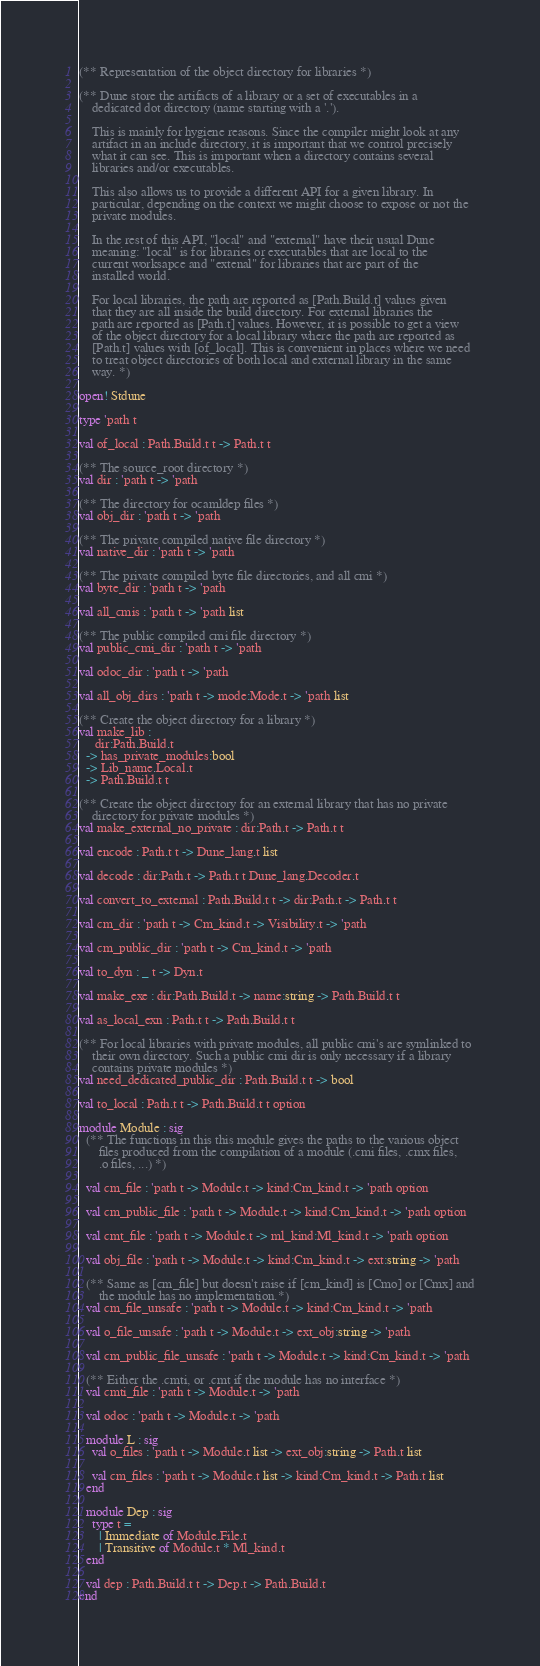<code> <loc_0><loc_0><loc_500><loc_500><_OCaml_>(** Representation of the object directory for libraries *)

(** Dune store the artifacts of a library or a set of executables in a
    dedicated dot directory (name starting with a '.').

    This is mainly for hygiene reasons. Since the compiler might look at any
    artifact in an include directory, it is important that we control precisely
    what it can see. This is important when a directory contains several
    libraries and/or executables.

    This also allows us to provide a different API for a given library. In
    particular, depending on the context we might choose to expose or not the
    private modules.

    In the rest of this API, "local" and "external" have their usual Dune
    meaning: "local" is for libraries or executables that are local to the
    current worksapce and "extenal" for libraries that are part of the
    installed world.

    For local libraries, the path are reported as [Path.Build.t] values given
    that they are all inside the build directory. For external libraries the
    path are reported as [Path.t] values. However, it is possible to get a view
    of the object directory for a local library where the path are reported as
    [Path.t] values with [of_local]. This is convenient in places where we need
    to treat object directories of both local and external library in the same
    way. *)

open! Stdune

type 'path t

val of_local : Path.Build.t t -> Path.t t

(** The source_root directory *)
val dir : 'path t -> 'path

(** The directory for ocamldep files *)
val obj_dir : 'path t -> 'path

(** The private compiled native file directory *)
val native_dir : 'path t -> 'path

(** The private compiled byte file directories, and all cmi *)
val byte_dir : 'path t -> 'path

val all_cmis : 'path t -> 'path list

(** The public compiled cmi file directory *)
val public_cmi_dir : 'path t -> 'path

val odoc_dir : 'path t -> 'path

val all_obj_dirs : 'path t -> mode:Mode.t -> 'path list

(** Create the object directory for a library *)
val make_lib :
     dir:Path.Build.t
  -> has_private_modules:bool
  -> Lib_name.Local.t
  -> Path.Build.t t

(** Create the object directory for an external library that has no private
    directory for private modules *)
val make_external_no_private : dir:Path.t -> Path.t t

val encode : Path.t t -> Dune_lang.t list

val decode : dir:Path.t -> Path.t t Dune_lang.Decoder.t

val convert_to_external : Path.Build.t t -> dir:Path.t -> Path.t t

val cm_dir : 'path t -> Cm_kind.t -> Visibility.t -> 'path

val cm_public_dir : 'path t -> Cm_kind.t -> 'path

val to_dyn : _ t -> Dyn.t

val make_exe : dir:Path.Build.t -> name:string -> Path.Build.t t

val as_local_exn : Path.t t -> Path.Build.t t

(** For local libraries with private modules, all public cmi's are symlinked to
    their own directory. Such a public cmi dir is only necessary if a library
    contains private modules *)
val need_dedicated_public_dir : Path.Build.t t -> bool

val to_local : Path.t t -> Path.Build.t t option

module Module : sig
  (** The functions in this this module gives the paths to the various object
      files produced from the compilation of a module (.cmi files, .cmx files,
      .o files, ...) *)

  val cm_file : 'path t -> Module.t -> kind:Cm_kind.t -> 'path option

  val cm_public_file : 'path t -> Module.t -> kind:Cm_kind.t -> 'path option

  val cmt_file : 'path t -> Module.t -> ml_kind:Ml_kind.t -> 'path option

  val obj_file : 'path t -> Module.t -> kind:Cm_kind.t -> ext:string -> 'path

  (** Same as [cm_file] but doesn't raise if [cm_kind] is [Cmo] or [Cmx] and
      the module has no implementation.*)
  val cm_file_unsafe : 'path t -> Module.t -> kind:Cm_kind.t -> 'path

  val o_file_unsafe : 'path t -> Module.t -> ext_obj:string -> 'path

  val cm_public_file_unsafe : 'path t -> Module.t -> kind:Cm_kind.t -> 'path

  (** Either the .cmti, or .cmt if the module has no interface *)
  val cmti_file : 'path t -> Module.t -> 'path

  val odoc : 'path t -> Module.t -> 'path

  module L : sig
    val o_files : 'path t -> Module.t list -> ext_obj:string -> Path.t list

    val cm_files : 'path t -> Module.t list -> kind:Cm_kind.t -> Path.t list
  end

  module Dep : sig
    type t =
      | Immediate of Module.File.t
      | Transitive of Module.t * Ml_kind.t
  end

  val dep : Path.Build.t t -> Dep.t -> Path.Build.t
end
</code> 